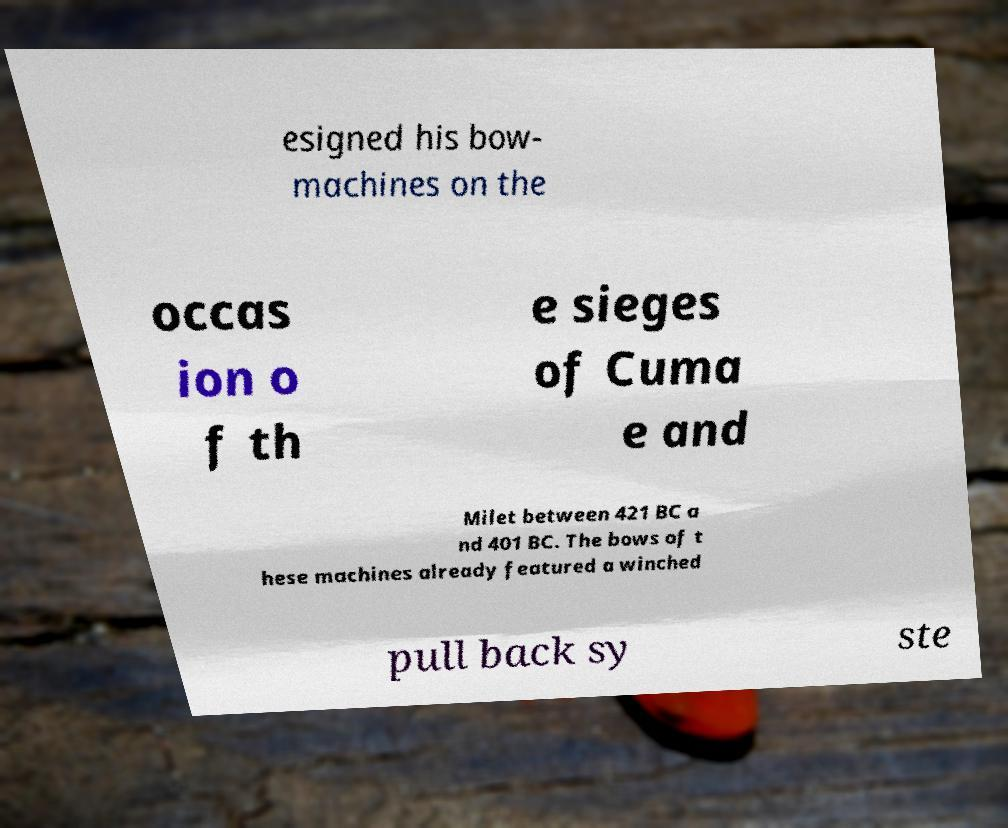Can you read and provide the text displayed in the image?This photo seems to have some interesting text. Can you extract and type it out for me? esigned his bow- machines on the occas ion o f th e sieges of Cuma e and Milet between 421 BC a nd 401 BC. The bows of t hese machines already featured a winched pull back sy ste 